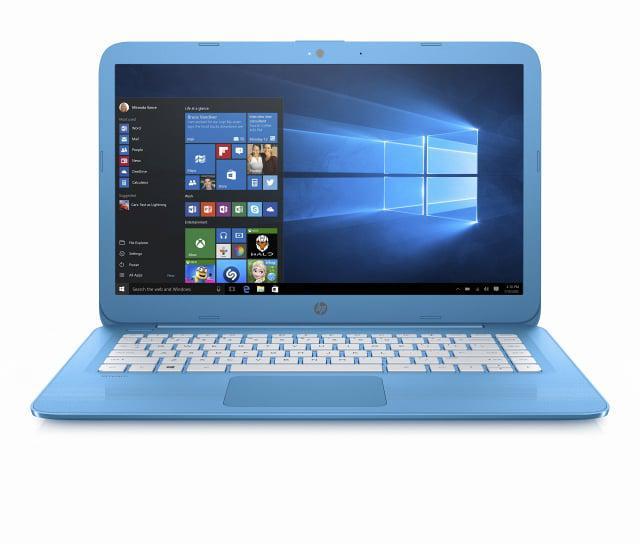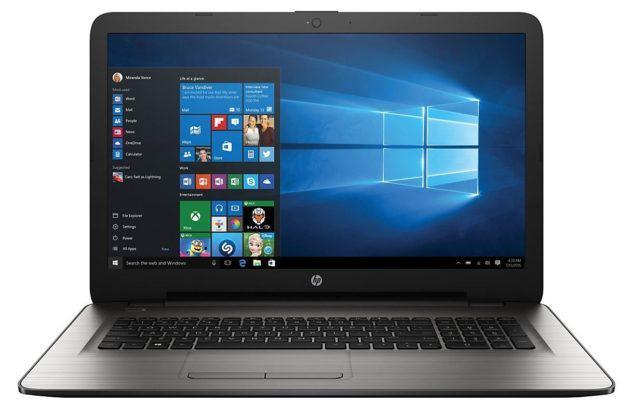The first image is the image on the left, the second image is the image on the right. Analyze the images presented: Is the assertion "The screen on the left is displayed head-on, and the screen on the right is angled facing left." valid? Answer yes or no. No. The first image is the image on the left, the second image is the image on the right. Assess this claim about the two images: "In at least one image there is one powered on laptop that top side is black and base is silver.". Correct or not? Answer yes or no. Yes. 